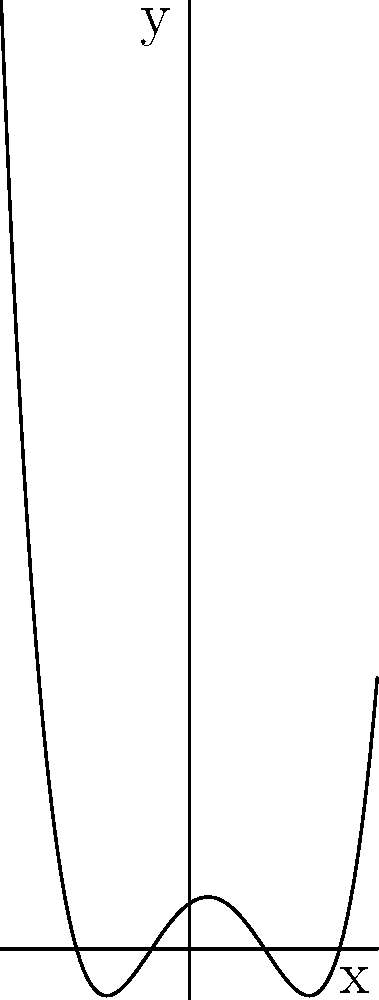Imagine you're debugging a Linux script that generates polynomial graphs. The script outputs a polynomial function with roots at $x = -3$, $x = -1$, $x = 2$, and $x = 4$. The end behavior shows the function approaching positive infinity as $x$ approaches both positive and negative infinity. Sketch the graph of this polynomial function. Let's approach this step-by-step, as if we're debugging a script:

1. Identify the degree: With 4 roots, this is a 4th degree polynomial.

2. Determine the sign of the leading coefficient:
   - Positive end behavior on both ends means the leading coefficient is positive.

3. Write the function in factored form:
   $f(x) = a(x+3)(x+1)(x-2)(x-4)$, where $a > 0$

4. Analyze the roots:
   - $x = -3$: crosses x-axis from below
   - $x = -1$: crosses x-axis from above
   - $x = 2$: crosses x-axis from below
   - $x = 4$: crosses x-axis from above

5. Sketch the graph:
   - Start from left with $y > 0$
   - Cross at $x = -3$ going down
   - Cross at $x = -1$ going up
   - Cross at $x = 2$ going down
   - Cross at $x = 4$ going up
   - Continue to positive infinity as $x$ increases

6. Verify end behavior:
   - As $x \to -\infty$, $f(x) \to +\infty$
   - As $x \to +\infty$, $f(x) \to +\infty$

This process is similar to debugging a script, where we analyze each component (roots, end behavior) to construct the final output (graph).
Answer: A curve crossing x-axis at -3, -1, 2, and 4, with positive y-values between -∞ and -3, -1 and 2, and 4 and +∞. 